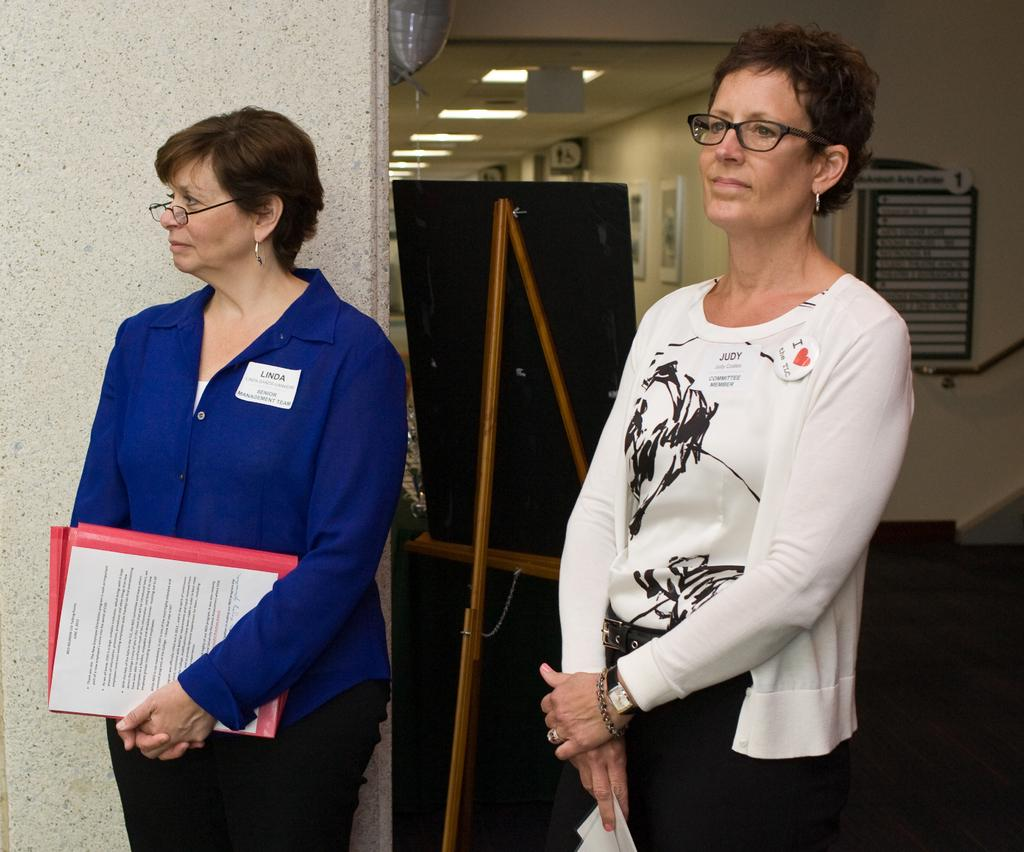How many people are present in the image? There are two people standing in the image. What are the people holding in their hands? The people are holding papers. What can be seen on the wall in the background? There are boards, a stand, and frames attached to the wall in the background. What type of lighting is visible in the image? There are lights visible in the image. What is the primary structure behind the people? There is a wall in the background. What type of twig is being used by the queen in the image? There is no queen or twig present in the image. How many yards are visible in the image? There is no yard visible in the image; it appears to be an indoor setting. 